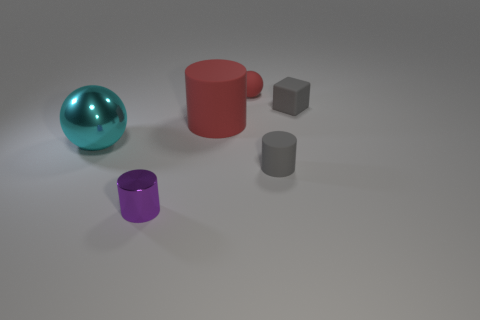Subtract 1 cylinders. How many cylinders are left? 2 Subtract all big red rubber cylinders. How many cylinders are left? 2 Add 1 big cyan things. How many objects exist? 7 Subtract all balls. How many objects are left? 4 Subtract 0 blue blocks. How many objects are left? 6 Subtract all big yellow shiny blocks. Subtract all large metal spheres. How many objects are left? 5 Add 4 cyan shiny balls. How many cyan shiny balls are left? 5 Add 2 big green balls. How many big green balls exist? 2 